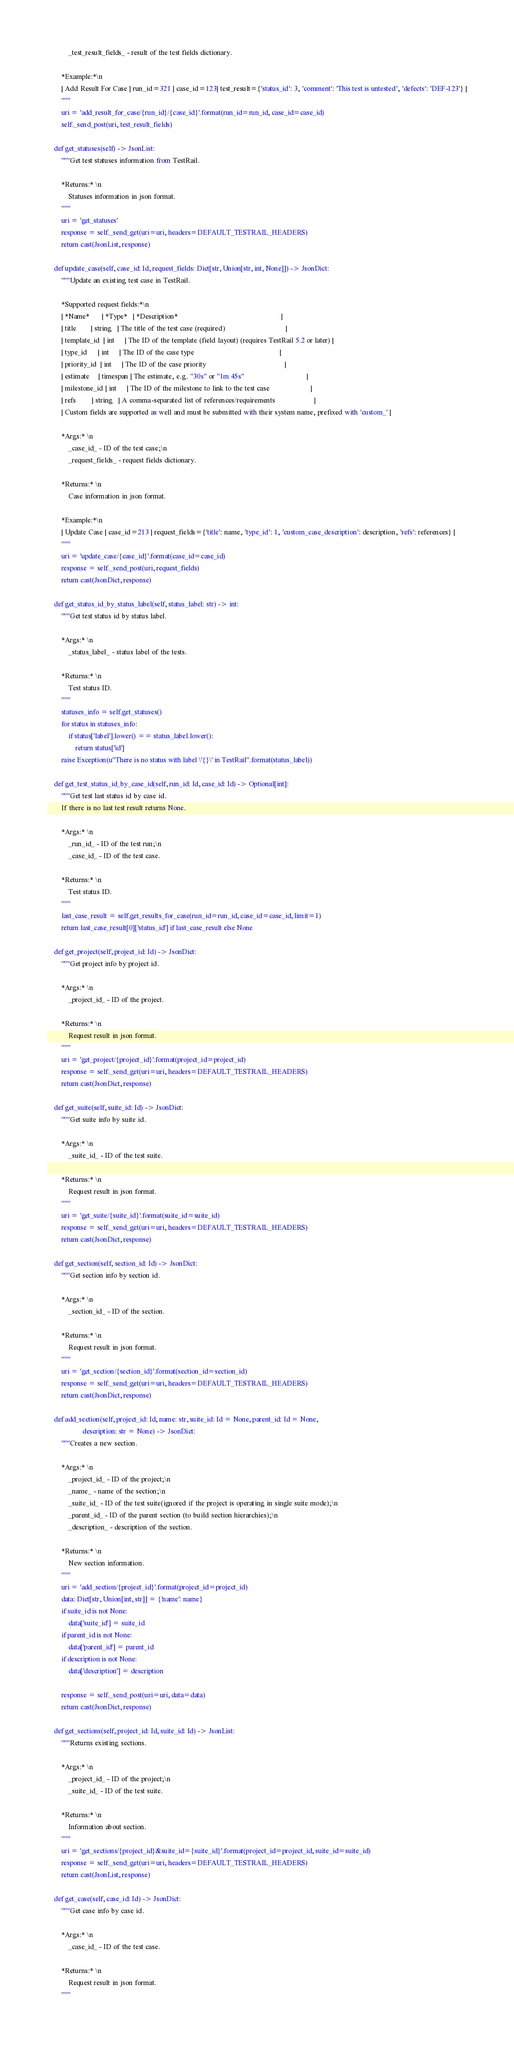Convert code to text. <code><loc_0><loc_0><loc_500><loc_500><_Python_>            _test_result_fields_ - result of the test fields dictionary.

        *Example:*\n
        | Add Result For Case | run_id=321 | case_id=123| test_result={'status_id': 3, 'comment': 'This test is untested', 'defects': 'DEF-123'} |
        """
        uri = 'add_result_for_case/{run_id}/{case_id}'.format(run_id=run_id, case_id=case_id)
        self._send_post(uri, test_result_fields)

    def get_statuses(self) -> JsonList:
        """Get test statuses information from TestRail.

        *Returns:* \n
            Statuses information in json format.
        """
        uri = 'get_statuses'
        response = self._send_get(uri=uri, headers=DEFAULT_TESTRAIL_HEADERS)
        return cast(JsonList, response)

    def update_case(self, case_id: Id, request_fields: Dict[str, Union[str, int, None]]) -> JsonDict:
        """Update an existing test case in TestRail.

        *Supported request fields:*\n
        | *Name*       | *Type*   | *Description*                                                          |
        | title        | string   | The title of the test case (required)                                  |
        | template_id  | int      | The ID of the template (field layout) (requires TestRail 5.2 or later) |
        | type_id      | int      | The ID of the case type                                                |
        | priority_id  | int      | The ID of the case priority                                            |
        | estimate     | timespan | The estimate, e.g. "30s" or "1m 45s"                                   |
        | milestone_id | int      | The ID of the milestone to link to the test case                       |
        | refs         | string   | A comma-separated list of references/requirements                      |
        | Custom fields are supported as well and must be submitted with their system name, prefixed with 'custom_' |

        *Args:* \n
            _case_id_ - ID of the test case;\n
            _request_fields_ - request fields dictionary.

        *Returns:* \n
            Case information in json format.

        *Example:*\n
        | Update Case | case_id=213 | request_fields={'title': name, 'type_id': 1, 'custom_case_description': description, 'refs': references} |
        """
        uri = 'update_case/{case_id}'.format(case_id=case_id)
        response = self._send_post(uri, request_fields)
        return cast(JsonDict, response)

    def get_status_id_by_status_label(self, status_label: str) -> int:
        """Get test status id by status label.

        *Args:* \n
            _status_label_ - status label of the tests.

        *Returns:* \n
            Test status ID.
        """
        statuses_info = self.get_statuses()
        for status in statuses_info:
            if status['label'].lower() == status_label.lower():
                return status['id']
        raise Exception(u"There is no status with label \'{}\' in TestRail".format(status_label))

    def get_test_status_id_by_case_id(self, run_id: Id, case_id: Id) -> Optional[int]:
        """Get test last status id by case id.
        If there is no last test result returns None.

        *Args:* \n
            _run_id_ - ID of the test run;\n
            _case_id_ - ID of the test case.

        *Returns:* \n
            Test status ID.
        """
        last_case_result = self.get_results_for_case(run_id=run_id, case_id=case_id, limit=1)
        return last_case_result[0]['status_id'] if last_case_result else None

    def get_project(self, project_id: Id) -> JsonDict:
        """Get project info by project id.

        *Args:* \n
            _project_id_ - ID of the project.

        *Returns:* \n
            Request result in json format.
        """
        uri = 'get_project/{project_id}'.format(project_id=project_id)
        response = self._send_get(uri=uri, headers=DEFAULT_TESTRAIL_HEADERS)
        return cast(JsonDict, response)

    def get_suite(self, suite_id: Id) -> JsonDict:
        """Get suite info by suite id.

        *Args:* \n
            _suite_id_ - ID of the test suite.

        *Returns:* \n
            Request result in json format.
        """
        uri = 'get_suite/{suite_id}'.format(suite_id=suite_id)
        response = self._send_get(uri=uri, headers=DEFAULT_TESTRAIL_HEADERS)
        return cast(JsonDict, response)

    def get_section(self, section_id: Id) -> JsonDict:
        """Get section info by section id.

        *Args:* \n
            _section_id_ - ID of the section.

        *Returns:* \n
            Request result in json format.
        """
        uri = 'get_section/{section_id}'.format(section_id=section_id)
        response = self._send_get(uri=uri, headers=DEFAULT_TESTRAIL_HEADERS)
        return cast(JsonDict, response)

    def add_section(self, project_id: Id, name: str, suite_id: Id = None, parent_id: Id = None,
                    description: str = None) -> JsonDict:
        """Creates a new section.

        *Args:* \n
            _project_id_ - ID of the project;\n
            _name_ - name of the section;\n
            _suite_id_ - ID of the test suite(ignored if the project is operating in single suite mode);\n
            _parent_id_ - ID of the parent section (to build section hierarchies);\n
            _description_ - description of the section.

        *Returns:* \n
            New section information.
        """
        uri = 'add_section/{project_id}'.format(project_id=project_id)
        data: Dict[str, Union[int, str]] = {'name': name}
        if suite_id is not None:
            data['suite_id'] = suite_id
        if parent_id is not None:
            data['parent_id'] = parent_id
        if description is not None:
            data['description'] = description

        response = self._send_post(uri=uri, data=data)
        return cast(JsonDict, response)

    def get_sections(self, project_id: Id, suite_id: Id) -> JsonList:
        """Returns existing sections.

        *Args:* \n
            _project_id_ - ID of the project;\n
            _suite_id_ - ID of the test suite.

        *Returns:* \n
            Information about section.
        """
        uri = 'get_sections/{project_id}&suite_id={suite_id}'.format(project_id=project_id, suite_id=suite_id)
        response = self._send_get(uri=uri, headers=DEFAULT_TESTRAIL_HEADERS)
        return cast(JsonList, response)

    def get_case(self, case_id: Id) -> JsonDict:
        """Get case info by case id.

        *Args:* \n
            _case_id_ - ID of the test case.

        *Returns:* \n
            Request result in json format.
        """</code> 